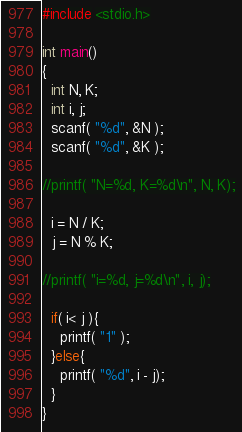Convert code to text. <code><loc_0><loc_0><loc_500><loc_500><_C_>#include <stdio.h>
 
int main()
{
  int N, K;
  int i, j;
  scanf( "%d", &N );
  scanf( "%d", &K );

//printf( "N=%d, K=%d\n", N, K);

  i = N / K;
  j = N % K;
  
//printf( "i=%d, j=%d\n", i, j);

  if( i< j ){
    printf( "1" );
  }else{
    printf( "%d", i - j);
  }
}</code> 